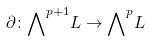<formula> <loc_0><loc_0><loc_500><loc_500>\partial \colon { \bigwedge } ^ { p + 1 } L \to { \bigwedge } ^ { p } L</formula> 